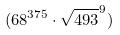<formula> <loc_0><loc_0><loc_500><loc_500>( 6 8 ^ { 3 7 5 } \cdot \sqrt { 4 9 3 } ^ { 9 } )</formula> 